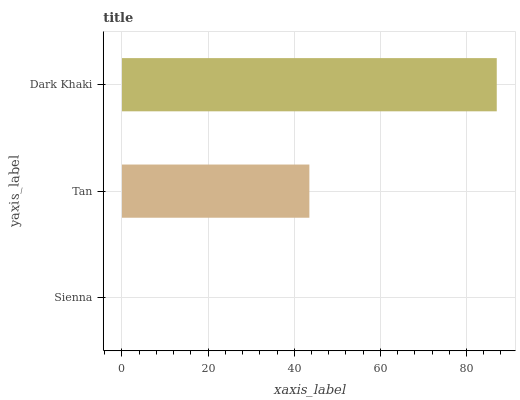Is Sienna the minimum?
Answer yes or no. Yes. Is Dark Khaki the maximum?
Answer yes or no. Yes. Is Tan the minimum?
Answer yes or no. No. Is Tan the maximum?
Answer yes or no. No. Is Tan greater than Sienna?
Answer yes or no. Yes. Is Sienna less than Tan?
Answer yes or no. Yes. Is Sienna greater than Tan?
Answer yes or no. No. Is Tan less than Sienna?
Answer yes or no. No. Is Tan the high median?
Answer yes or no. Yes. Is Tan the low median?
Answer yes or no. Yes. Is Sienna the high median?
Answer yes or no. No. Is Sienna the low median?
Answer yes or no. No. 